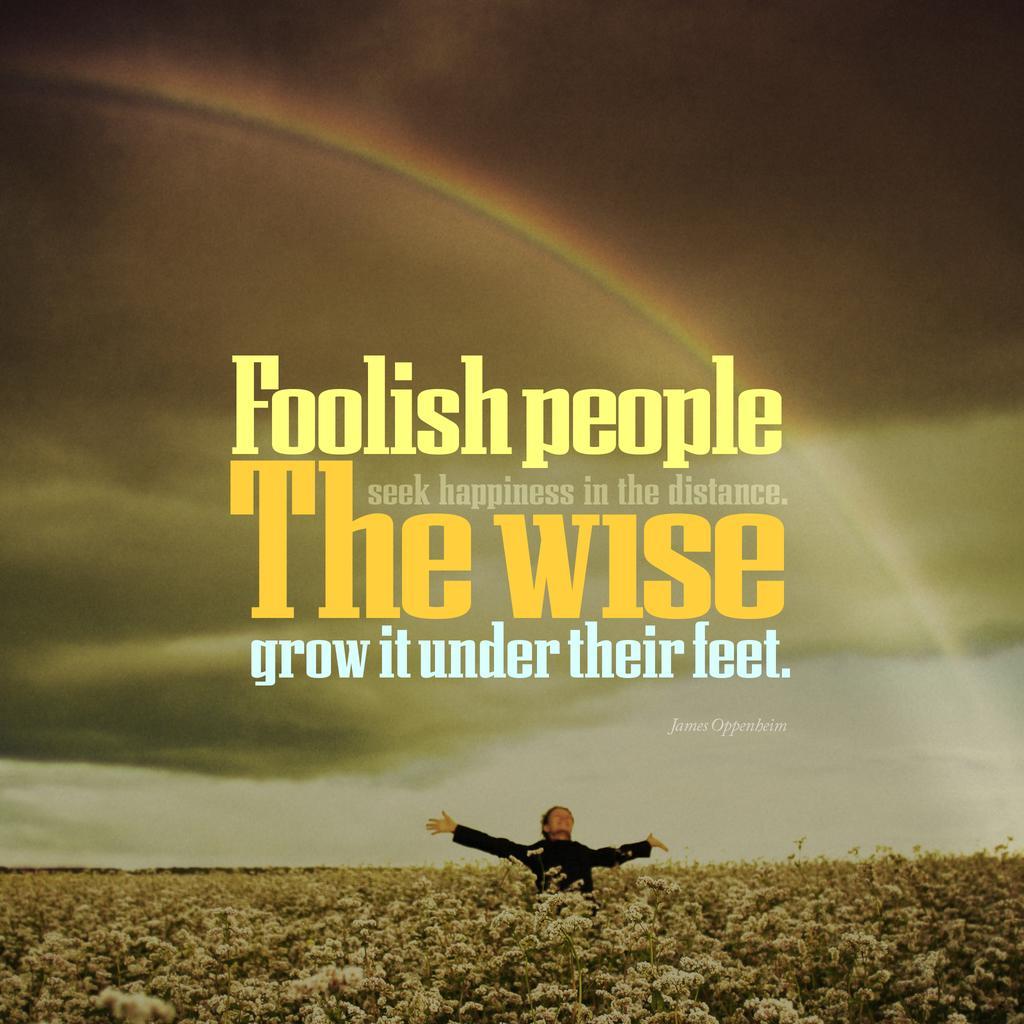Describe this image in one or two sentences. In this image I can see the person standing and wearing the black color dress. There are many trees around the person. In the back I can see the sky and the rainbow. I can also see something is written on the image. 